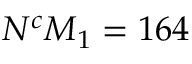<formula> <loc_0><loc_0><loc_500><loc_500>N ^ { c } M _ { 1 } = 1 6 4</formula> 